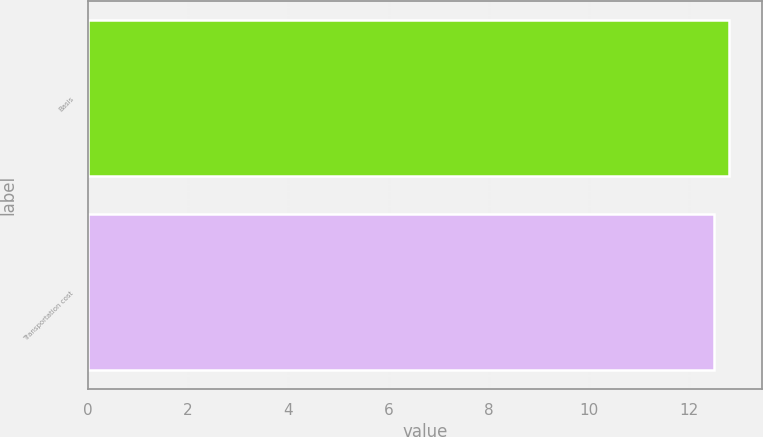<chart> <loc_0><loc_0><loc_500><loc_500><bar_chart><fcel>Basis<fcel>Transportation cost<nl><fcel>12.8<fcel>12.5<nl></chart> 